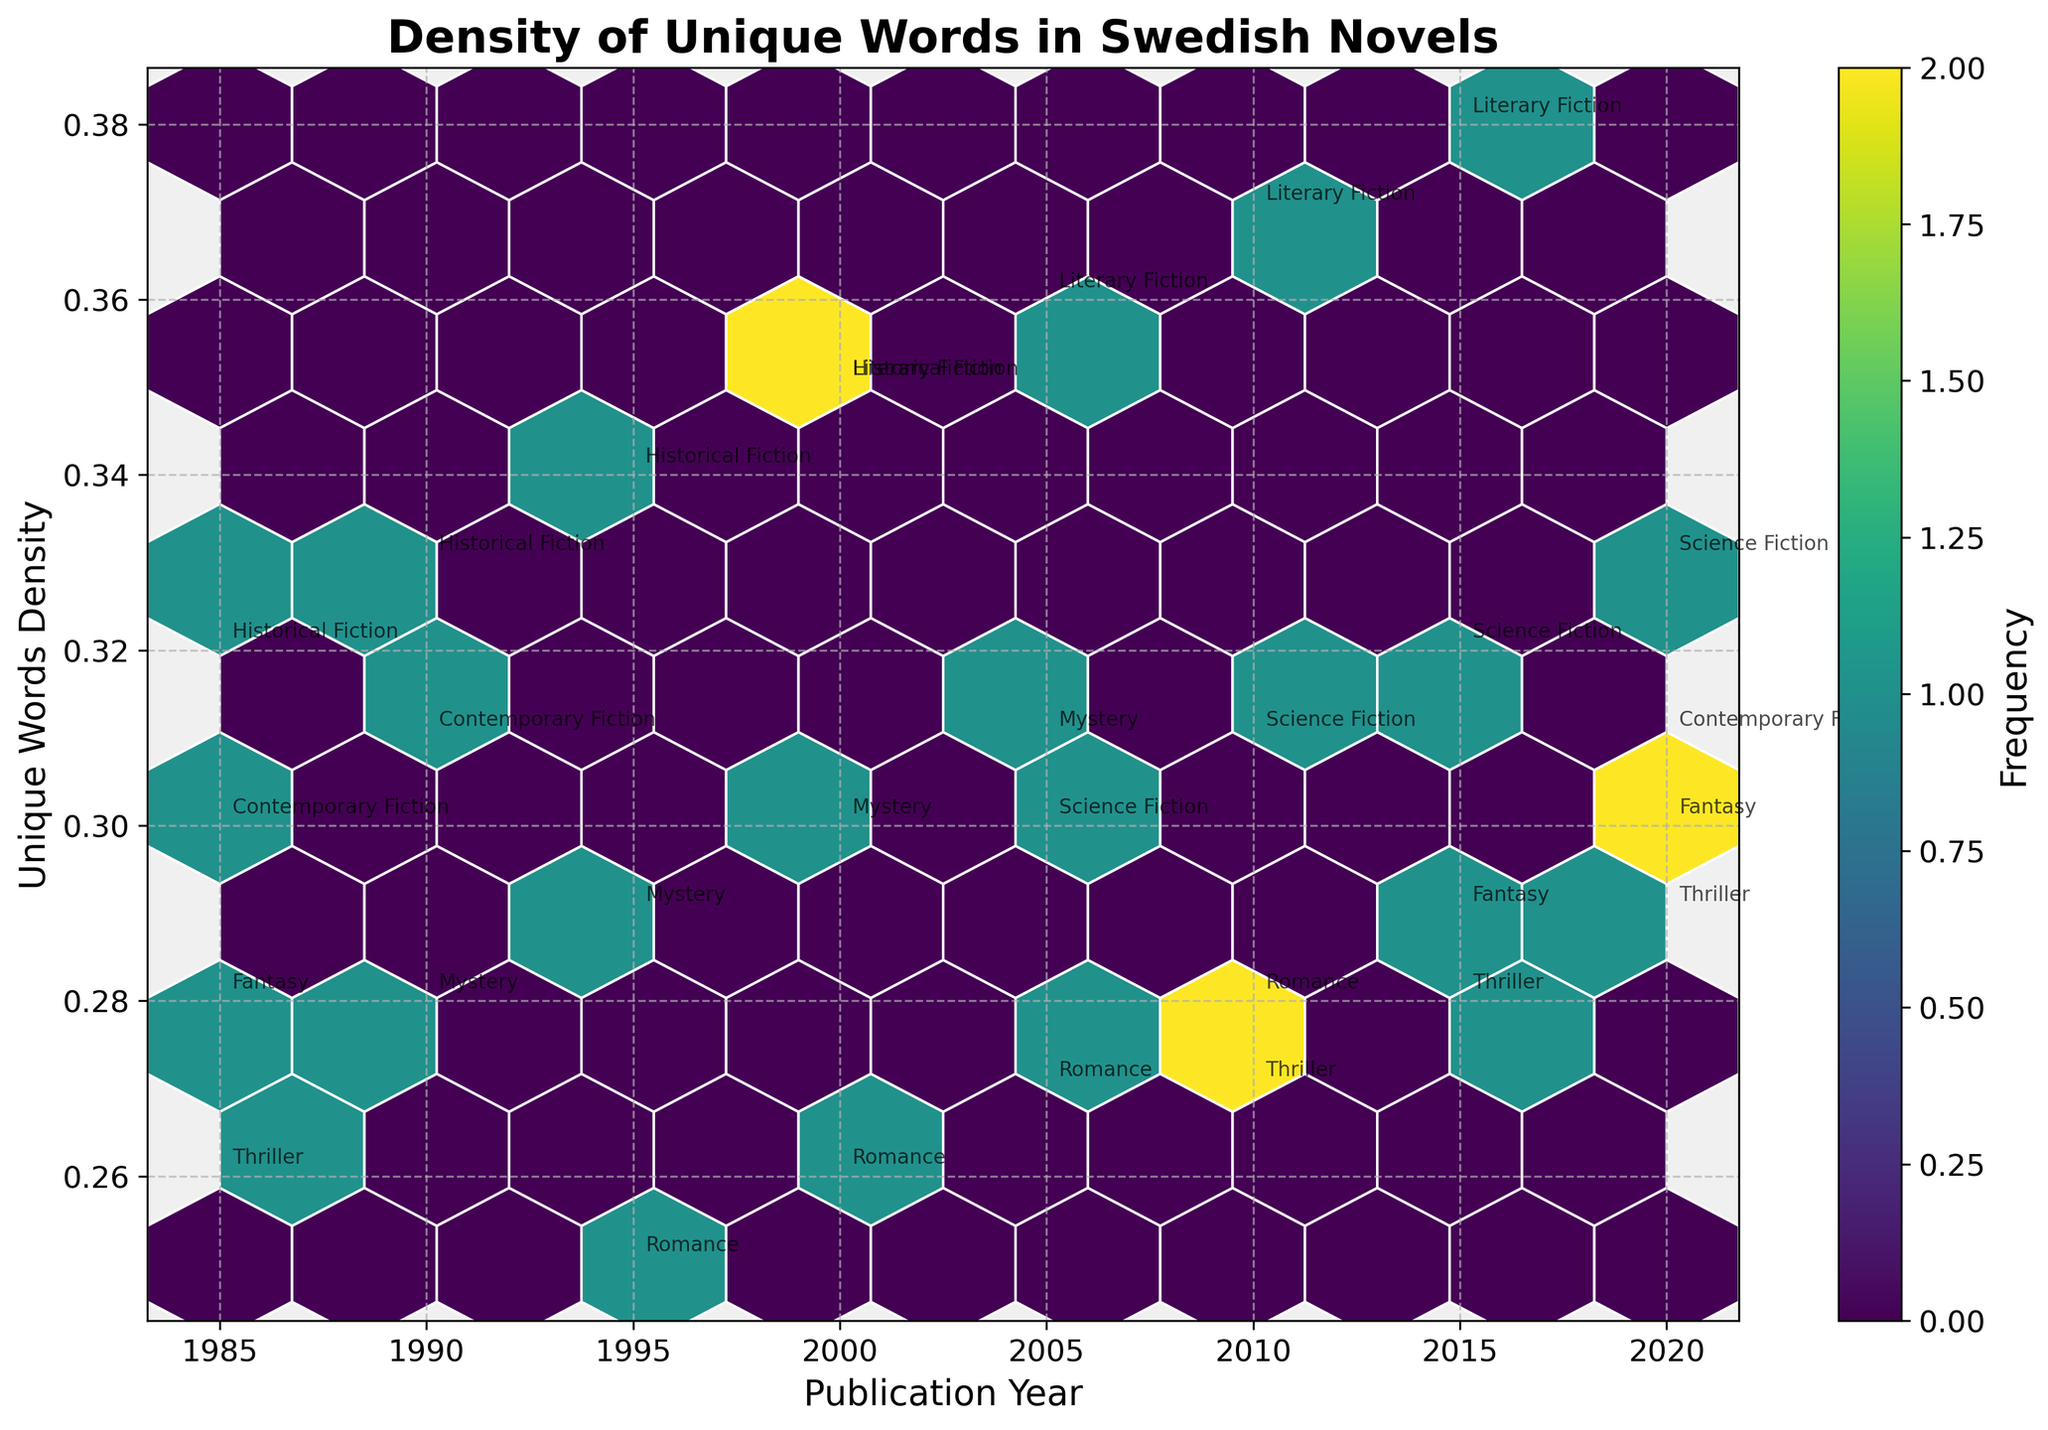What is the title of the plot? The title is usually located at the top of the plot. From our script, the title is set to "Density of Unique Words in Swedish Novels."
Answer: Density of Unique Words in Swedish Novels Which year has the highest density for Literary Fiction? Look for the points labeled "Literary Fiction" and check their vertical position (Unique Words Density). The highest point is in 2015 with a density of 0.38.
Answer: 2015 What is the range of Unique Words Density for the Thriller genre? Identify all the points labeled "Thriller" and note their corresponding densities. The range is from 0.26 (1985) to 0.29 (2020).
Answer: 0.26 to 0.29 What is the most common density range for the data in the plot? The color intensity of the hexagons indicates frequency. The most common density range appears in the green hexagons, which includes densities around 0.28 to 0.32.
Answer: 0.28 to 0.32 Which genre showed the most consistency in Unique Words Density across the years? Consistency can be evaluated by less variation in densities. Mystery has density values 0.28, 0.29, 0.30, and 0.31, implying a stable pattern.
Answer: Mystery Which genre had the highest density of unique words in the most recent year available? Check the points with the latest year (2020) and note the highest density value. Literary Fiction in 2015 had the highest density of 0.38.
Answer: Science Fiction Did any genre appear at the same publication year multiple times? If so, which genre and year? Scan through the publication years and see if any genre appears more than once for a particular year. Historical Fiction appears in 1985 and 1990.
Answer: Historical Fiction in 1985 and 1990 Is there a trend in the density of unique words in Historical Fiction over the years? Look at the data points labeled "Historical Fiction" and observe the pattern. Densities are 0.32 (1985), 0.33 (1990), 0.34 (1995), 0.35 (2000). There's a generally increasing trend.
Answer: Increasing trend What is the average density of unique words for all the genres collectively in 2005? Locate all the densities for the year 2005, sum them and divide by the number of points. Densities: 0.30 (Science Fiction), 0.36 (Literary Fiction), 0.27 (Romance), 0.31 (Mystery). Average = (0.30 + 0.36 + 0.27 + 0.31) / 4 = 1.24 / 4 = 0.31
Answer: 0.31 